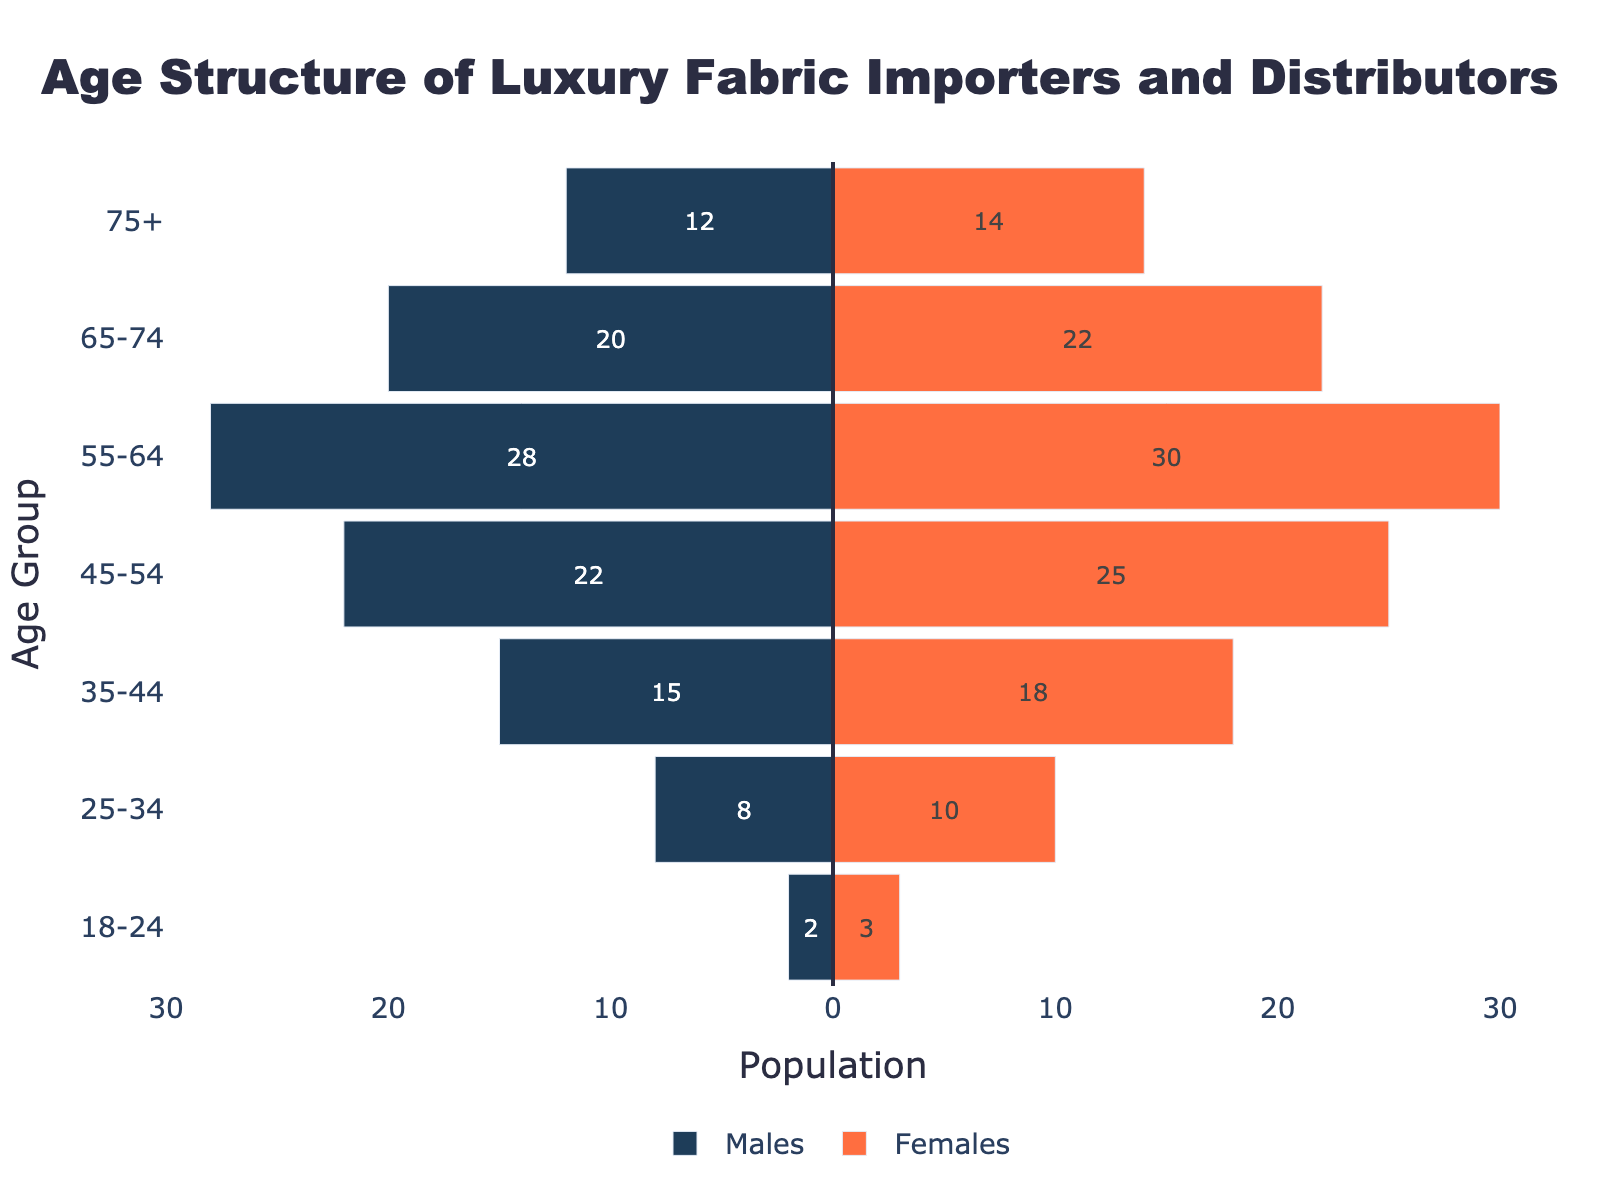What is the title of the figure? The title is usually found at the top of the figure and provides a summary of what the figure represents. In this case, it's "Age Structure of Luxury Fabric Importers and Distributors".
Answer: Age Structure of Luxury Fabric Importers and Distributors What is the color used to represent Males and Females? The males are represented by a dark blue color, and the females are represented by a bright orange color.
Answer: Dark blue for Males, Bright orange for Females Which age group has the highest number of males? By observing the length of the bars on the left side representing males, the age group 55-64 has the longest bar, indicating the highest number of males.
Answer: 55-64 How many more females are there in the 45-54 age group compared to males? For the 45-54 age group, count the number of females (25) and males (22). Subtract the number of males from the number of females: 25 - 22 = 3.
Answer: 3 What is the combined total population (both males and females) in the 35-44 age group? Add the number of males and females in the 35-44 age group: 15 (males) + 18 (females) = 33.
Answer: 33 Which gender has a higher population in the age group 75+? Compare the number of males (12) to the number of females (14) in the age group 75+. Since 14 is greater than 12, females have a higher population in this group.
Answer: Females What is the difference between the number of females in the 65-74 age group and the number of females in the 55-64 age group? Subtract the number of females in the 55-64 age group (30) from the number of females in the 65-74 age group (22): 30 - 22 = -8.
Answer: -8 Calculate the total number of people in the age groups below 35 years. Sum the total number of males and females from the age groups 18-24 and 25-34: (2+3) + (8+10) = 23.
Answer: 23 Which age group shows the most balanced gender distribution? Check for an age group where the difference between males and females is the smallest. The age group 75+ has males (12) and females (14) with a difference of 2.
Answer: 75+ What is the total population represented in the figure? Sum the total numbers for males and females across all age groups: (2+8+15+22+28+20+12) + (3+10+18+25+30+22+14) = 173.
Answer: 173 